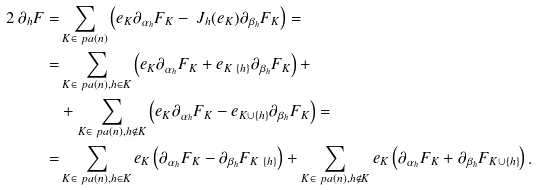Convert formula to latex. <formula><loc_0><loc_0><loc_500><loc_500>2 \, \partial _ { h } F = & \sum _ { K \in \ p a ( n ) } \left ( e _ { K } \partial _ { \alpha _ { h } } F _ { K } - \ J _ { h } ( e _ { K } ) \partial _ { \beta _ { h } } F _ { K } \right ) = \\ = & \sum _ { K \in \ p a ( n ) , h \in K } \left ( e _ { K } \partial _ { \alpha _ { h } } F _ { K } + e _ { K \ \{ h \} } \partial _ { \beta _ { h } } F _ { K } \right ) + \\ & + \sum _ { K \in \ p a ( n ) , h \not \in K } \left ( e _ { K } \partial _ { \alpha _ { h } } F _ { K } - e _ { K \cup \{ h \} } \partial _ { \beta _ { h } } F _ { K } \right ) = \\ = & \sum _ { K \in \ p a ( n ) , h \in K } e _ { K } \left ( \partial _ { \alpha _ { h } } F _ { K } - \partial _ { \beta _ { h } } F _ { K \ \{ h \} } \right ) + \sum _ { K \in \ p a ( n ) , h \not \in K } e _ { K } \left ( \partial _ { \alpha _ { h } } F _ { K } + \partial _ { \beta _ { h } } F _ { K \cup \{ h \} } \right ) .</formula> 